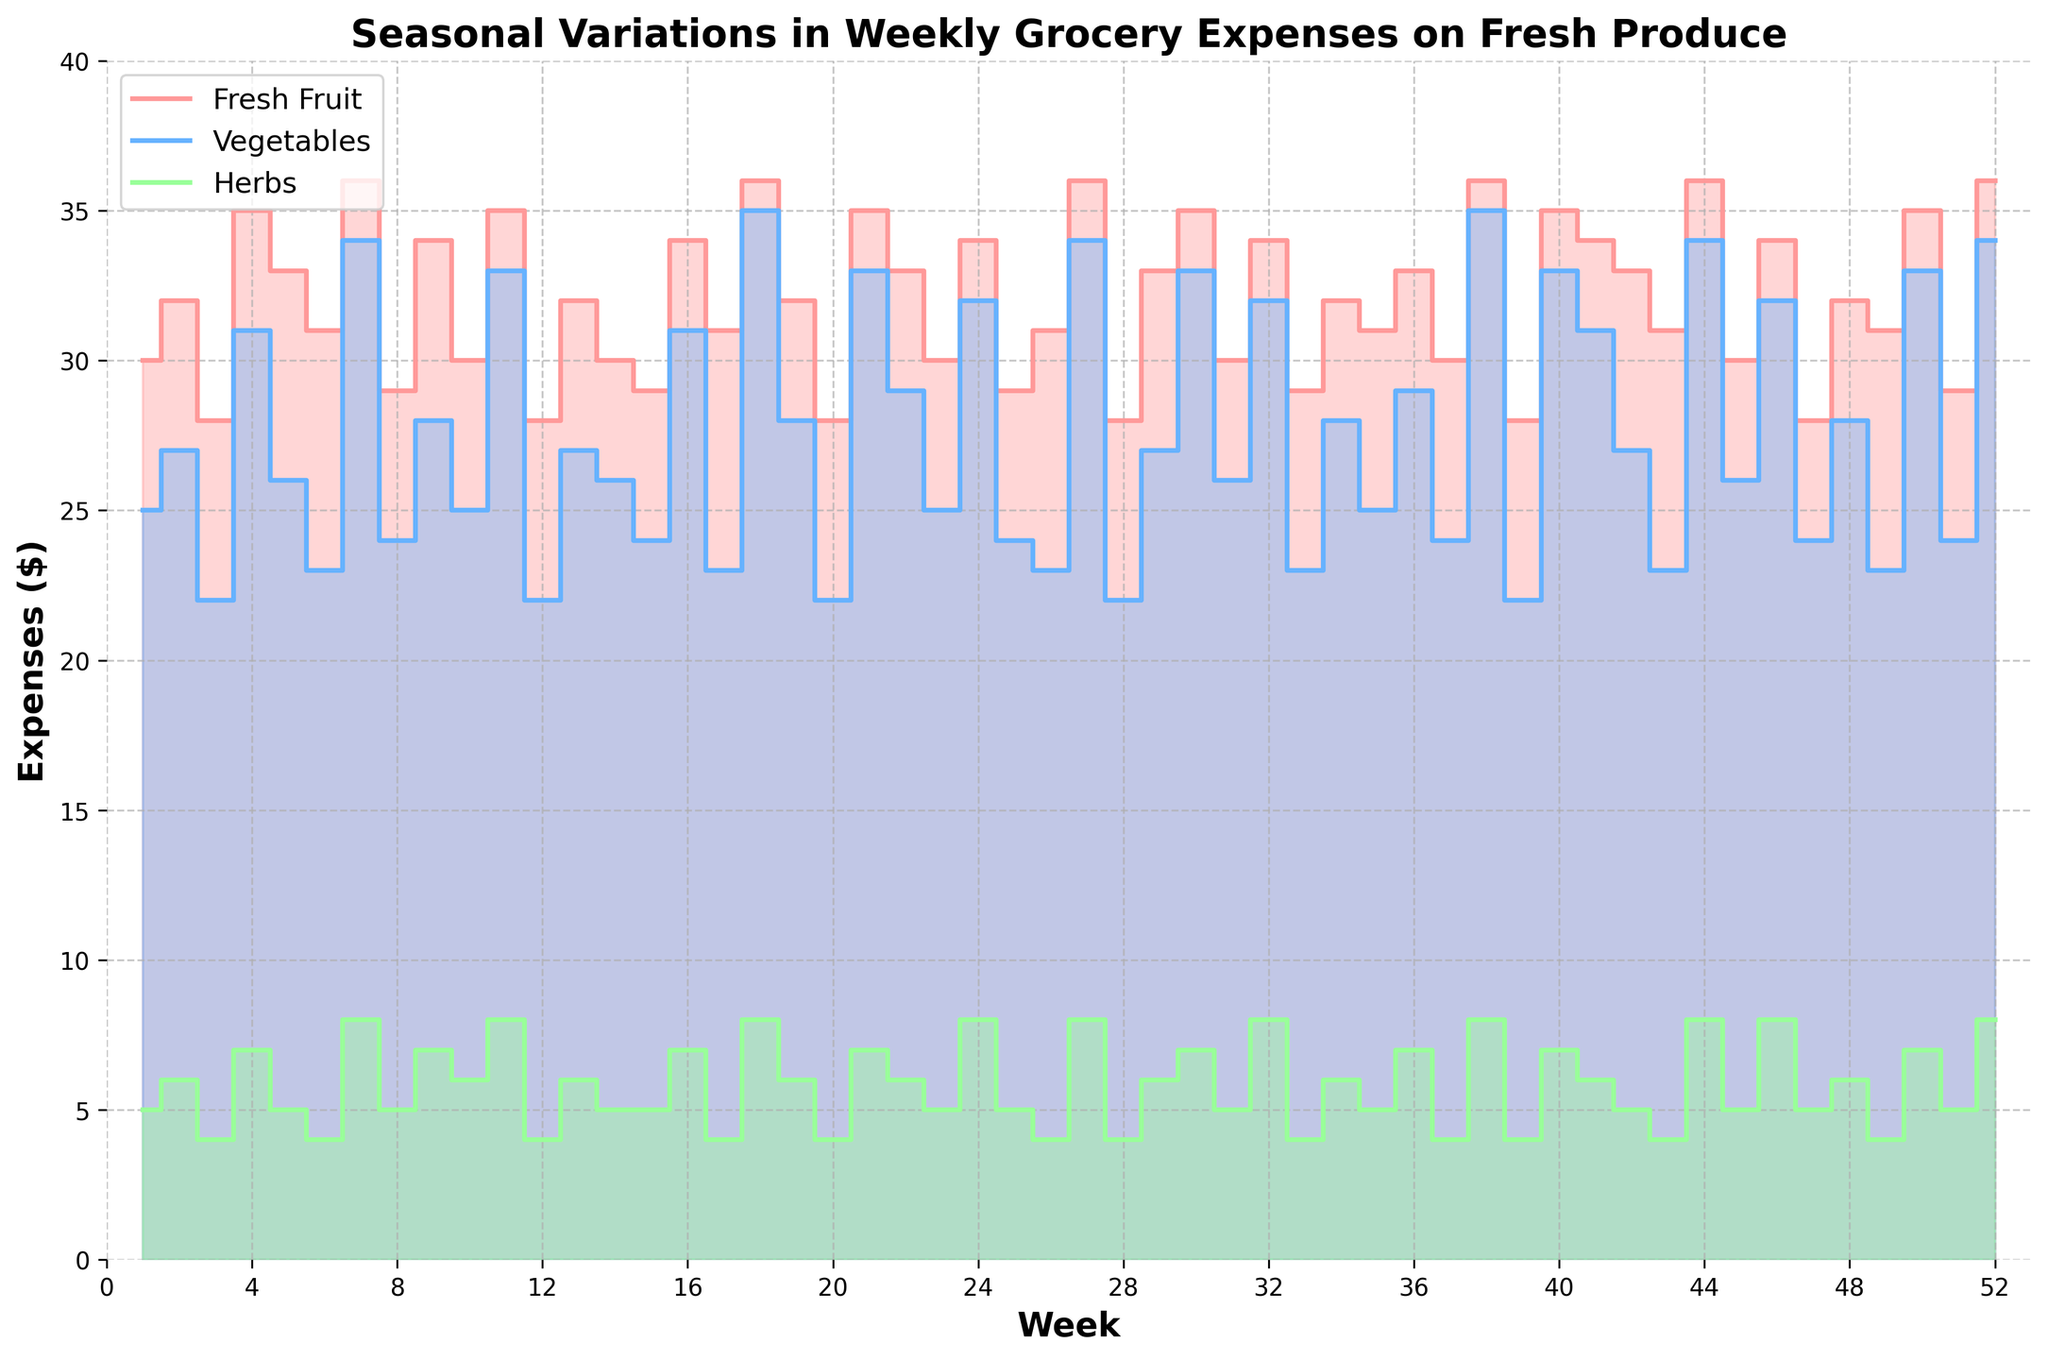What is the title of the figure? The title is usually found at the top of the figure and provides a summary of what the chart is about.
Answer: Seasonal Variations in Weekly Grocery Expenses on Fresh Produce What are the units of measurement on the y-axis? The y-axis commonly represents the magnitude of the variable being measured, and in this case, it is labeled with dollar signs to indicate expenses.
Answer: Dollars ($) Which category has the highest expense in Week 7? By looking at Week 7 on the x-axis and checking the highest position on the y-axis associated with it, we can identify the category with the largest value. This can also be confirmed by the color coding.
Answer: Vegetables Across all weeks, which type of produce expense remains the lowest? To determine this, inspect the three colored areas individually throughout the chart. The colored area consistently at the bottom, with the smallest numerical interval from the x-axis, indicates the lowest expenses.
Answer: Herbs Compare the expenses for Fresh Fruit and Vegetables in Week 12. Which is higher and by how much? Locate Week 12 on the x-axis and compare the stepped heights of the Fresh Fruit and Vegetables at this point, finding the difference in their expenses. Fresh Fruit expenses are $28 and Vegetables are $22, then the subtraction yields the difference.
Answer: Fresh Fruit is higher by $6 What is the overall trend in expenses for Vegetables from Week 1 to Week 52? Observe the color-coded section for Vegetables from the beginning to the end. Identify the general movement, whether it increases, decreases, or fluctuates, in the plot. This will summarize the trend.
Answer: Fluctuating How much did the total expenses on fresh produce increase from Week 2 to Week 3? Locate Week 2 and Week 3 on the x-axis, read the step heights for the total expenses for each week, calculate the difference by subtracting the value of Week 2 from Week 3. Total expenses in Week 2 are $65 and Week 3 are $54.
Answer: Decreased by $11 What weeks have the highest expenses for Herbs, and what are the amounts? Examine the plot for significant peaks in the Herbs section (green) along the x-axis, noting the Weeks where these peaks occur and their corresponding y-values.
Answer: Weeks 7, 11, 18, 27, 38, 44, 52 with $8 each What is the average expense on Fresh Fruit for every 4 weeks? Sum the expenses on Fresh Fruit for weeks 1 to 4, divide by 4, and repeat this process throughout the intervals for each chunk of 4 weeks up to Week 52, then take the general average of those values.
Answer: Approximately $31.54 